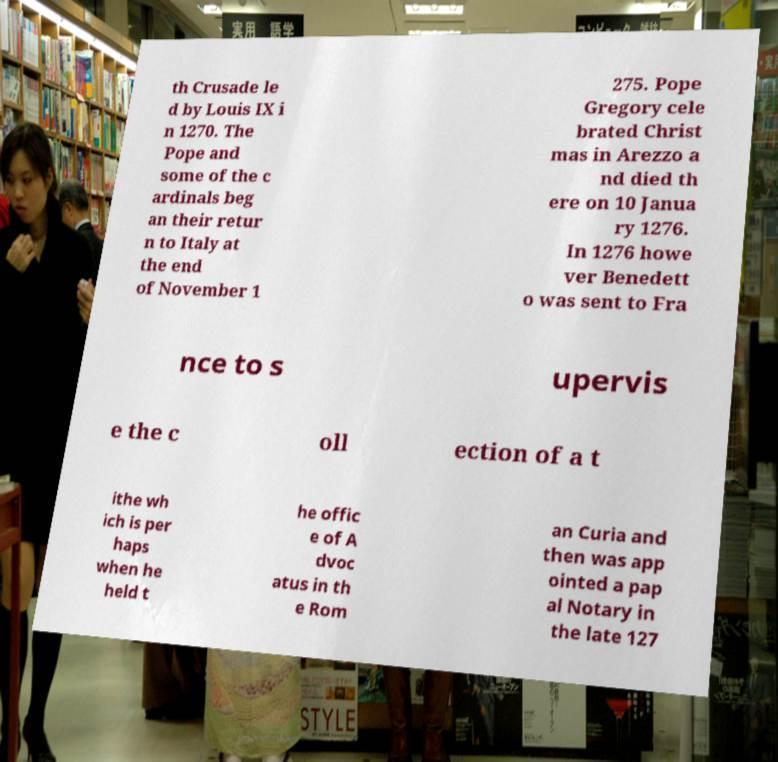Please identify and transcribe the text found in this image. th Crusade le d by Louis IX i n 1270. The Pope and some of the c ardinals beg an their retur n to Italy at the end of November 1 275. Pope Gregory cele brated Christ mas in Arezzo a nd died th ere on 10 Janua ry 1276. In 1276 howe ver Benedett o was sent to Fra nce to s upervis e the c oll ection of a t ithe wh ich is per haps when he held t he offic e of A dvoc atus in th e Rom an Curia and then was app ointed a pap al Notary in the late 127 